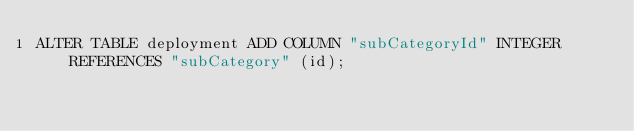Convert code to text. <code><loc_0><loc_0><loc_500><loc_500><_SQL_>ALTER TABLE deployment ADD COLUMN "subCategoryId" INTEGER REFERENCES "subCategory" (id);
</code> 